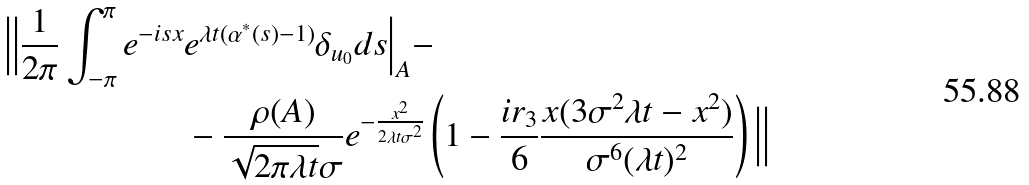Convert formula to latex. <formula><loc_0><loc_0><loc_500><loc_500>\Big | \Big | \frac { 1 } { 2 \pi } \int _ { - \pi } ^ { \pi } e ^ { - i s x } & e ^ { \lambda t ( \alpha ^ { * } ( s ) - 1 ) } \delta _ { u _ { 0 } } d s \Big | _ { A } - \\ & - \frac { \rho ( A ) } { \sqrt { 2 \pi \lambda t } \sigma } e ^ { - \frac { x ^ { 2 } } { 2 \lambda t \sigma ^ { 2 } } } \left ( 1 - \frac { i r _ { 3 } } { 6 } \frac { x ( 3 \sigma ^ { 2 } \lambda t - x ^ { 2 } ) } { \sigma ^ { 6 } ( \lambda t ) ^ { 2 } } \right ) \Big | \Big |</formula> 